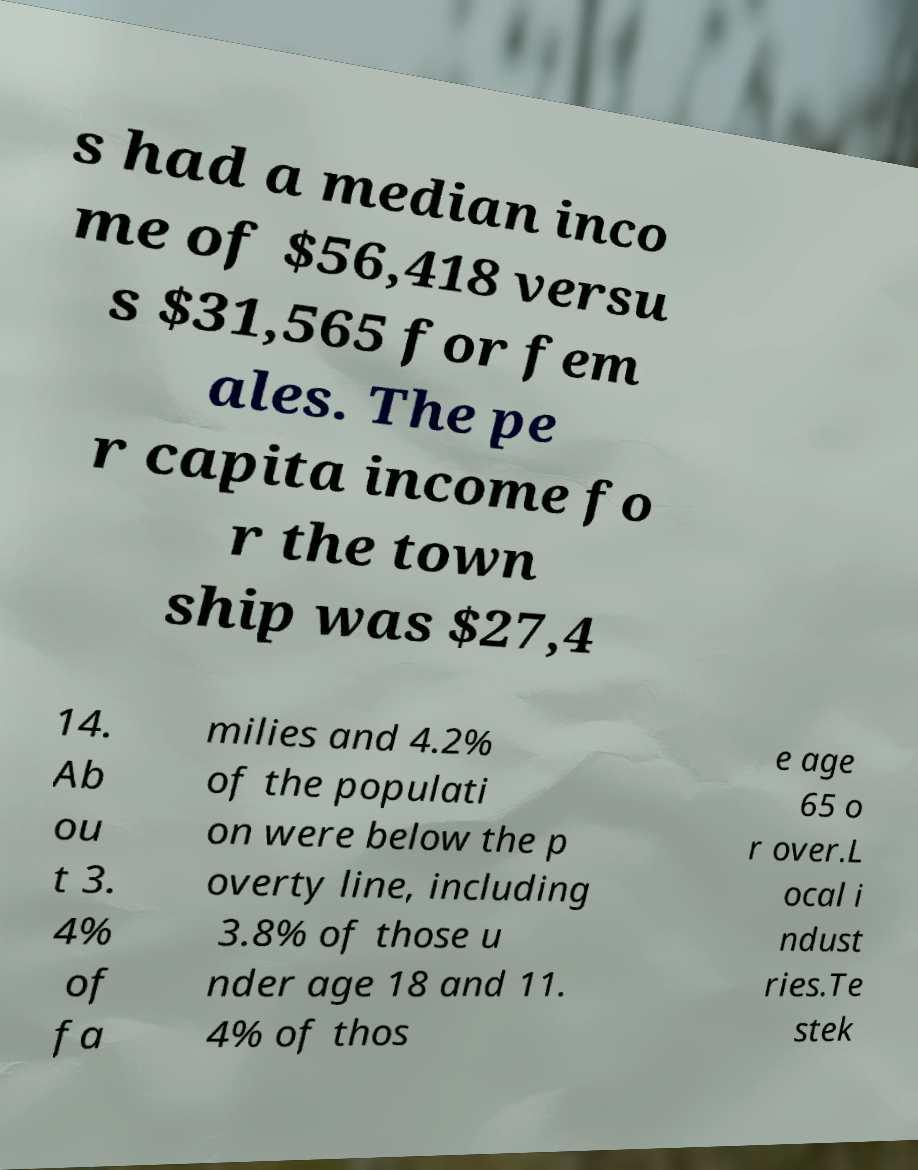I need the written content from this picture converted into text. Can you do that? s had a median inco me of $56,418 versu s $31,565 for fem ales. The pe r capita income fo r the town ship was $27,4 14. Ab ou t 3. 4% of fa milies and 4.2% of the populati on were below the p overty line, including 3.8% of those u nder age 18 and 11. 4% of thos e age 65 o r over.L ocal i ndust ries.Te stek 